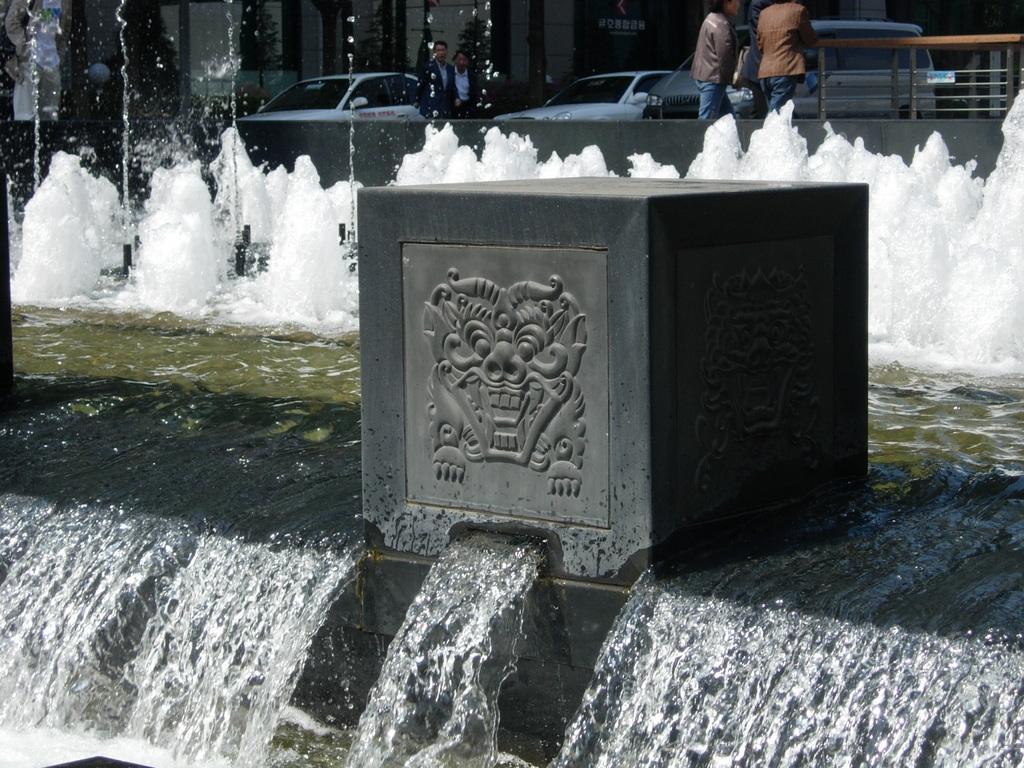Please provide a concise description of this image. In this image in the front there is water. In the center there is an object which is in the shape of box with some art on it. In the background there is water fountain and there are persons standing, there are cars and trees and buildings and there is a railing. 